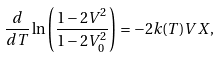Convert formula to latex. <formula><loc_0><loc_0><loc_500><loc_500>\frac { d } { d T } \ln \left ( \frac { 1 - 2 V ^ { 2 } } { 1 - 2 V _ { 0 } ^ { 2 } } \right ) = - 2 k ( T ) V X ,</formula> 